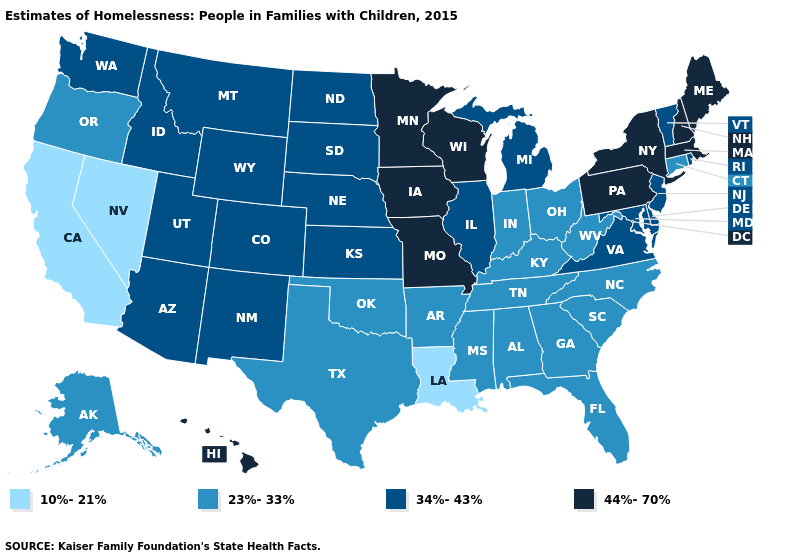What is the highest value in the MidWest ?
Answer briefly. 44%-70%. Among the states that border Missouri , which have the highest value?
Quick response, please. Iowa. Does the first symbol in the legend represent the smallest category?
Keep it brief. Yes. What is the value of Washington?
Be succinct. 34%-43%. What is the lowest value in states that border North Carolina?
Keep it brief. 23%-33%. What is the value of Maine?
Give a very brief answer. 44%-70%. What is the lowest value in the USA?
Quick response, please. 10%-21%. Among the states that border Indiana , does Ohio have the highest value?
Be succinct. No. Does New Hampshire have the highest value in the USA?
Be succinct. Yes. What is the highest value in states that border Minnesota?
Answer briefly. 44%-70%. What is the highest value in the USA?
Write a very short answer. 44%-70%. Name the states that have a value in the range 44%-70%?
Write a very short answer. Hawaii, Iowa, Maine, Massachusetts, Minnesota, Missouri, New Hampshire, New York, Pennsylvania, Wisconsin. What is the highest value in the USA?
Quick response, please. 44%-70%. Name the states that have a value in the range 23%-33%?
Write a very short answer. Alabama, Alaska, Arkansas, Connecticut, Florida, Georgia, Indiana, Kentucky, Mississippi, North Carolina, Ohio, Oklahoma, Oregon, South Carolina, Tennessee, Texas, West Virginia. What is the highest value in the MidWest ?
Give a very brief answer. 44%-70%. 